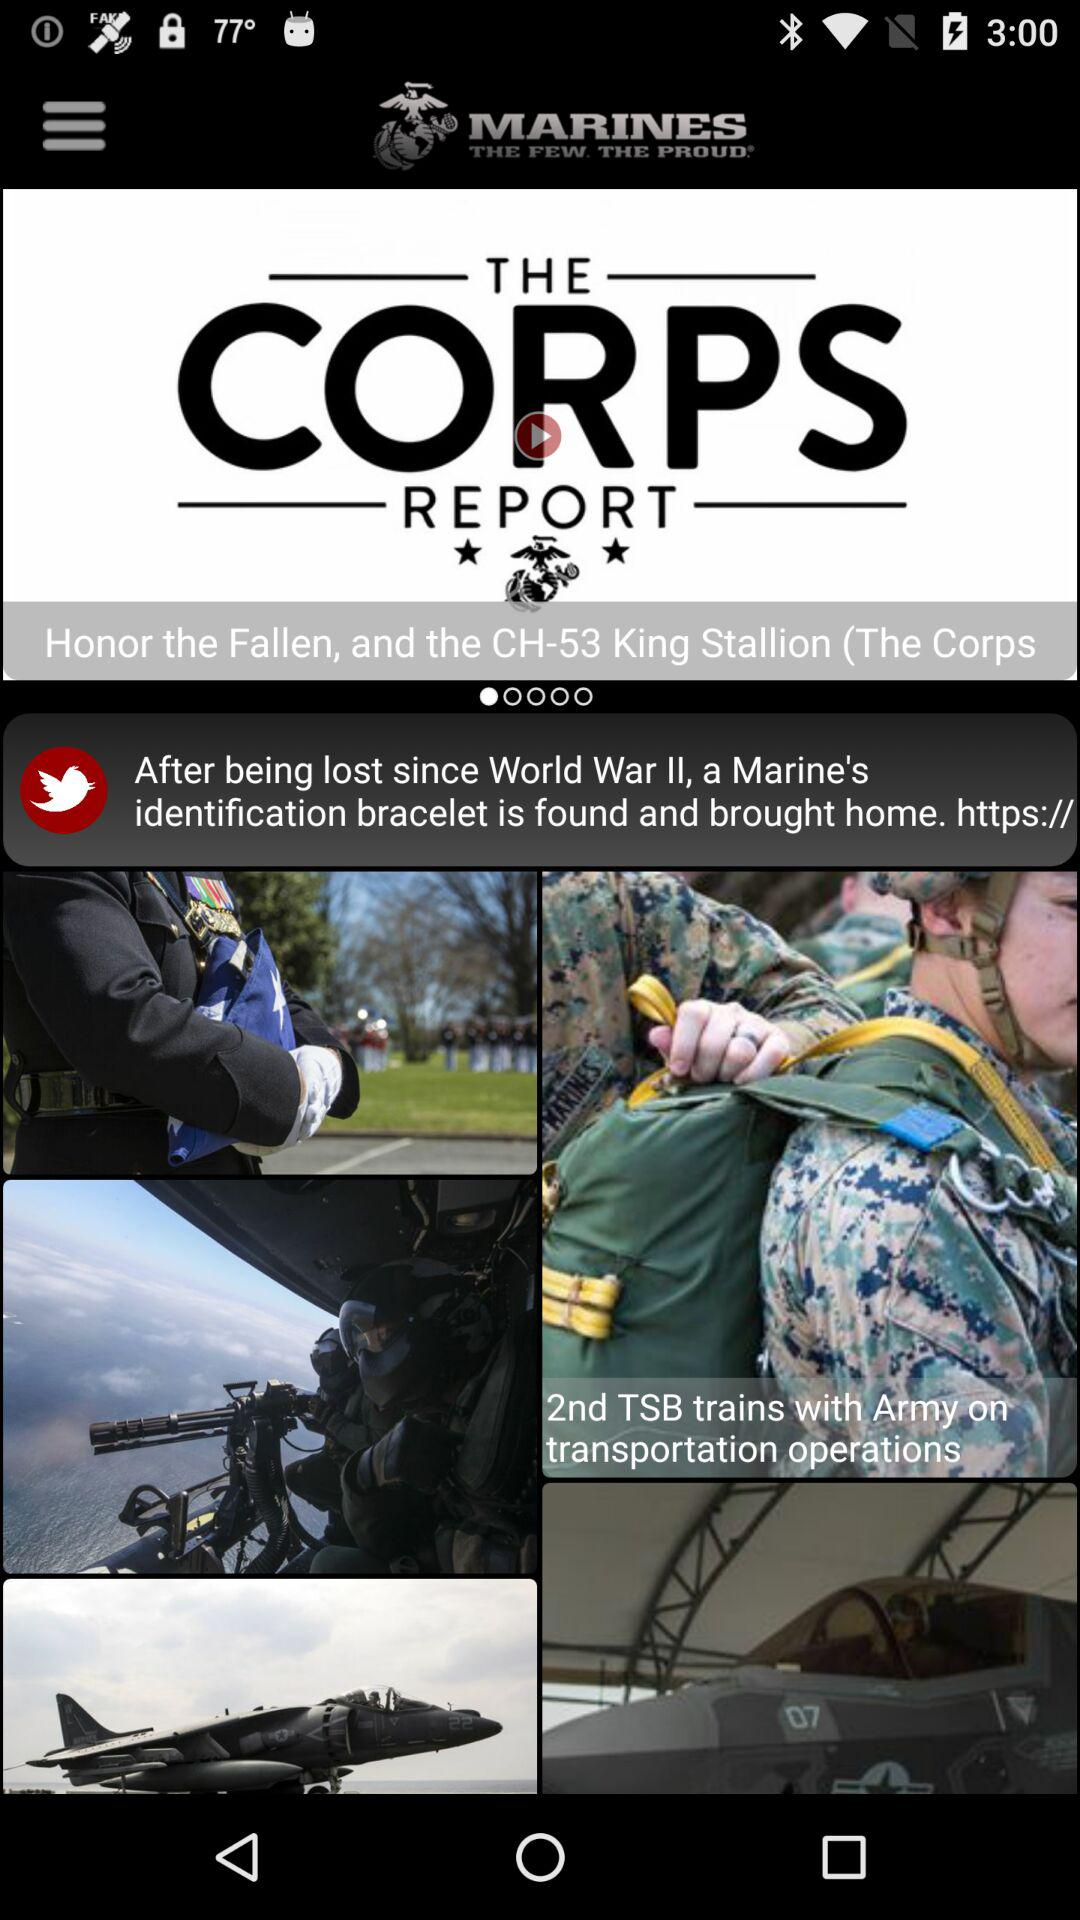What is the name of the application? The name of the application is "MARINES". 